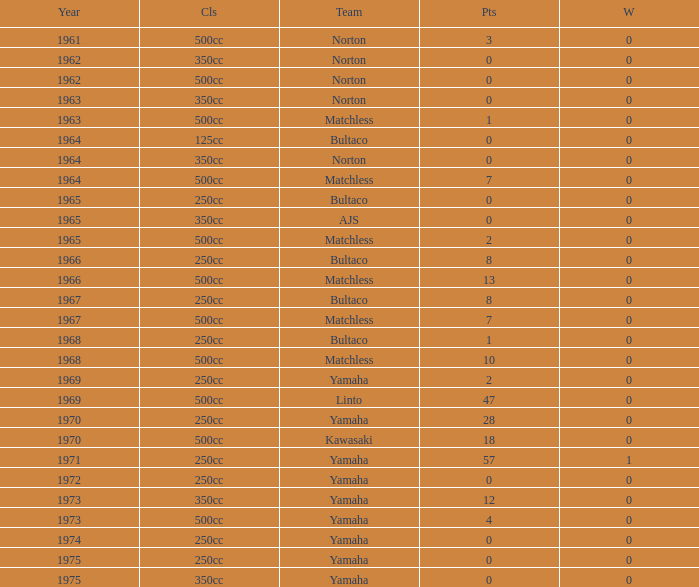What is the average wins in 250cc class for Bultaco with 8 points later than 1966? 0.0. 